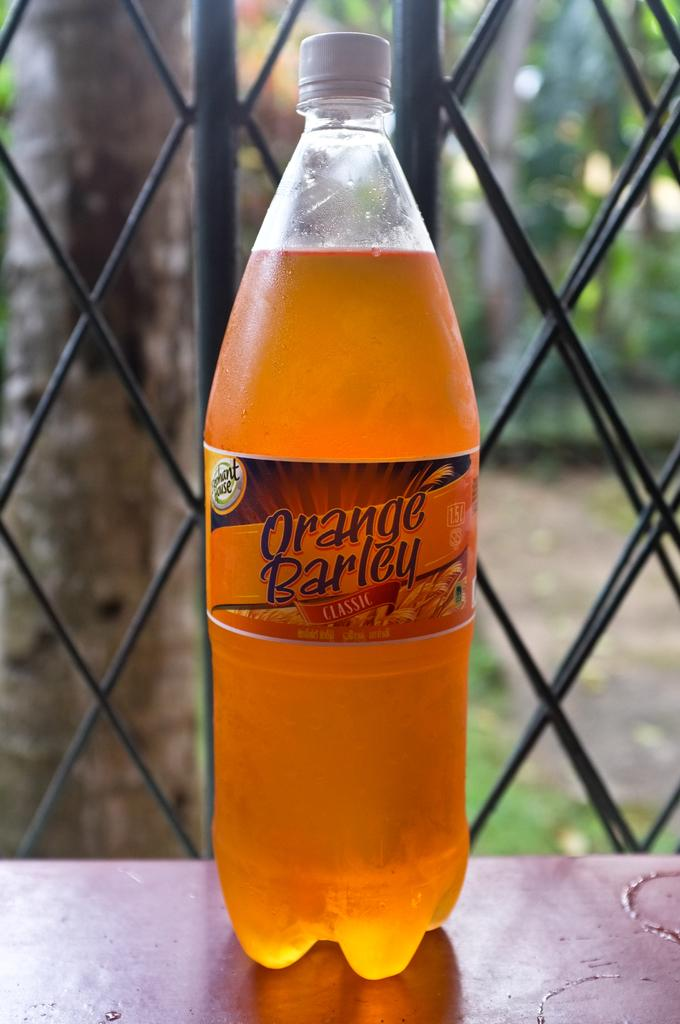What object is visible on the table in the image? There is a bottle on a table in the image. What can be seen in the background of the image? There are trees and plants in the background of the image. What type of game is being played in the image? There is no game being played in the image; it features a bottle on a table and trees and plants in the background. What angle is the bottle positioned at in the image? The angle at which the bottle is positioned cannot be determined from the image alone. 